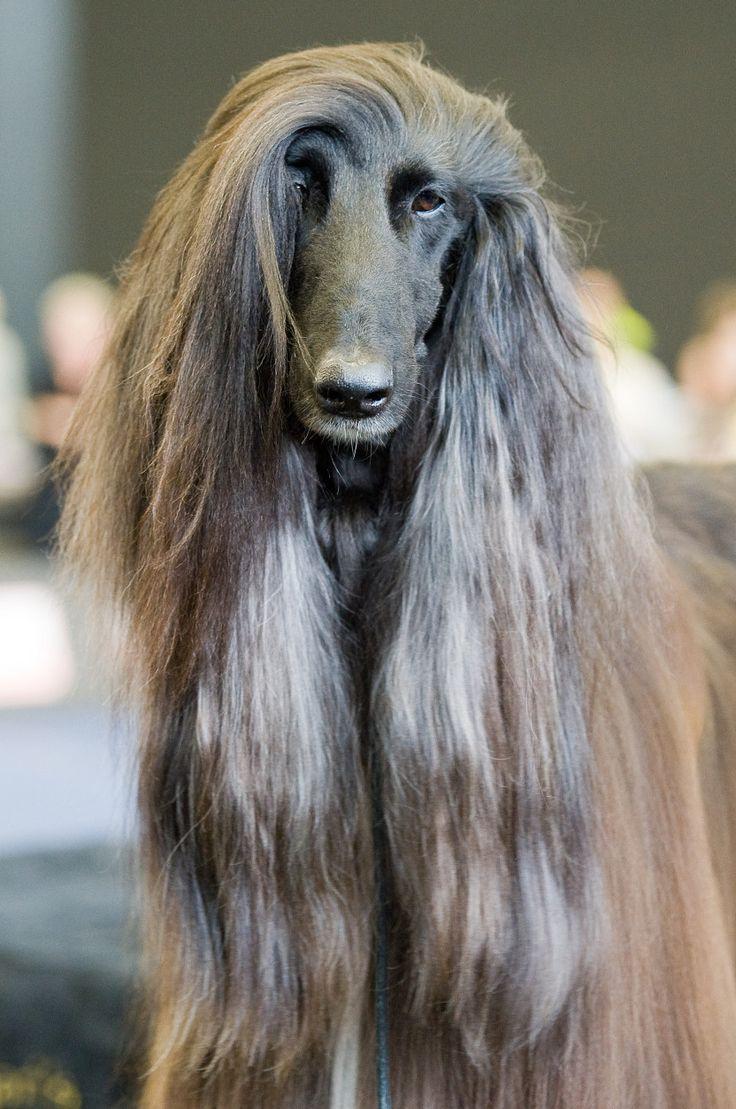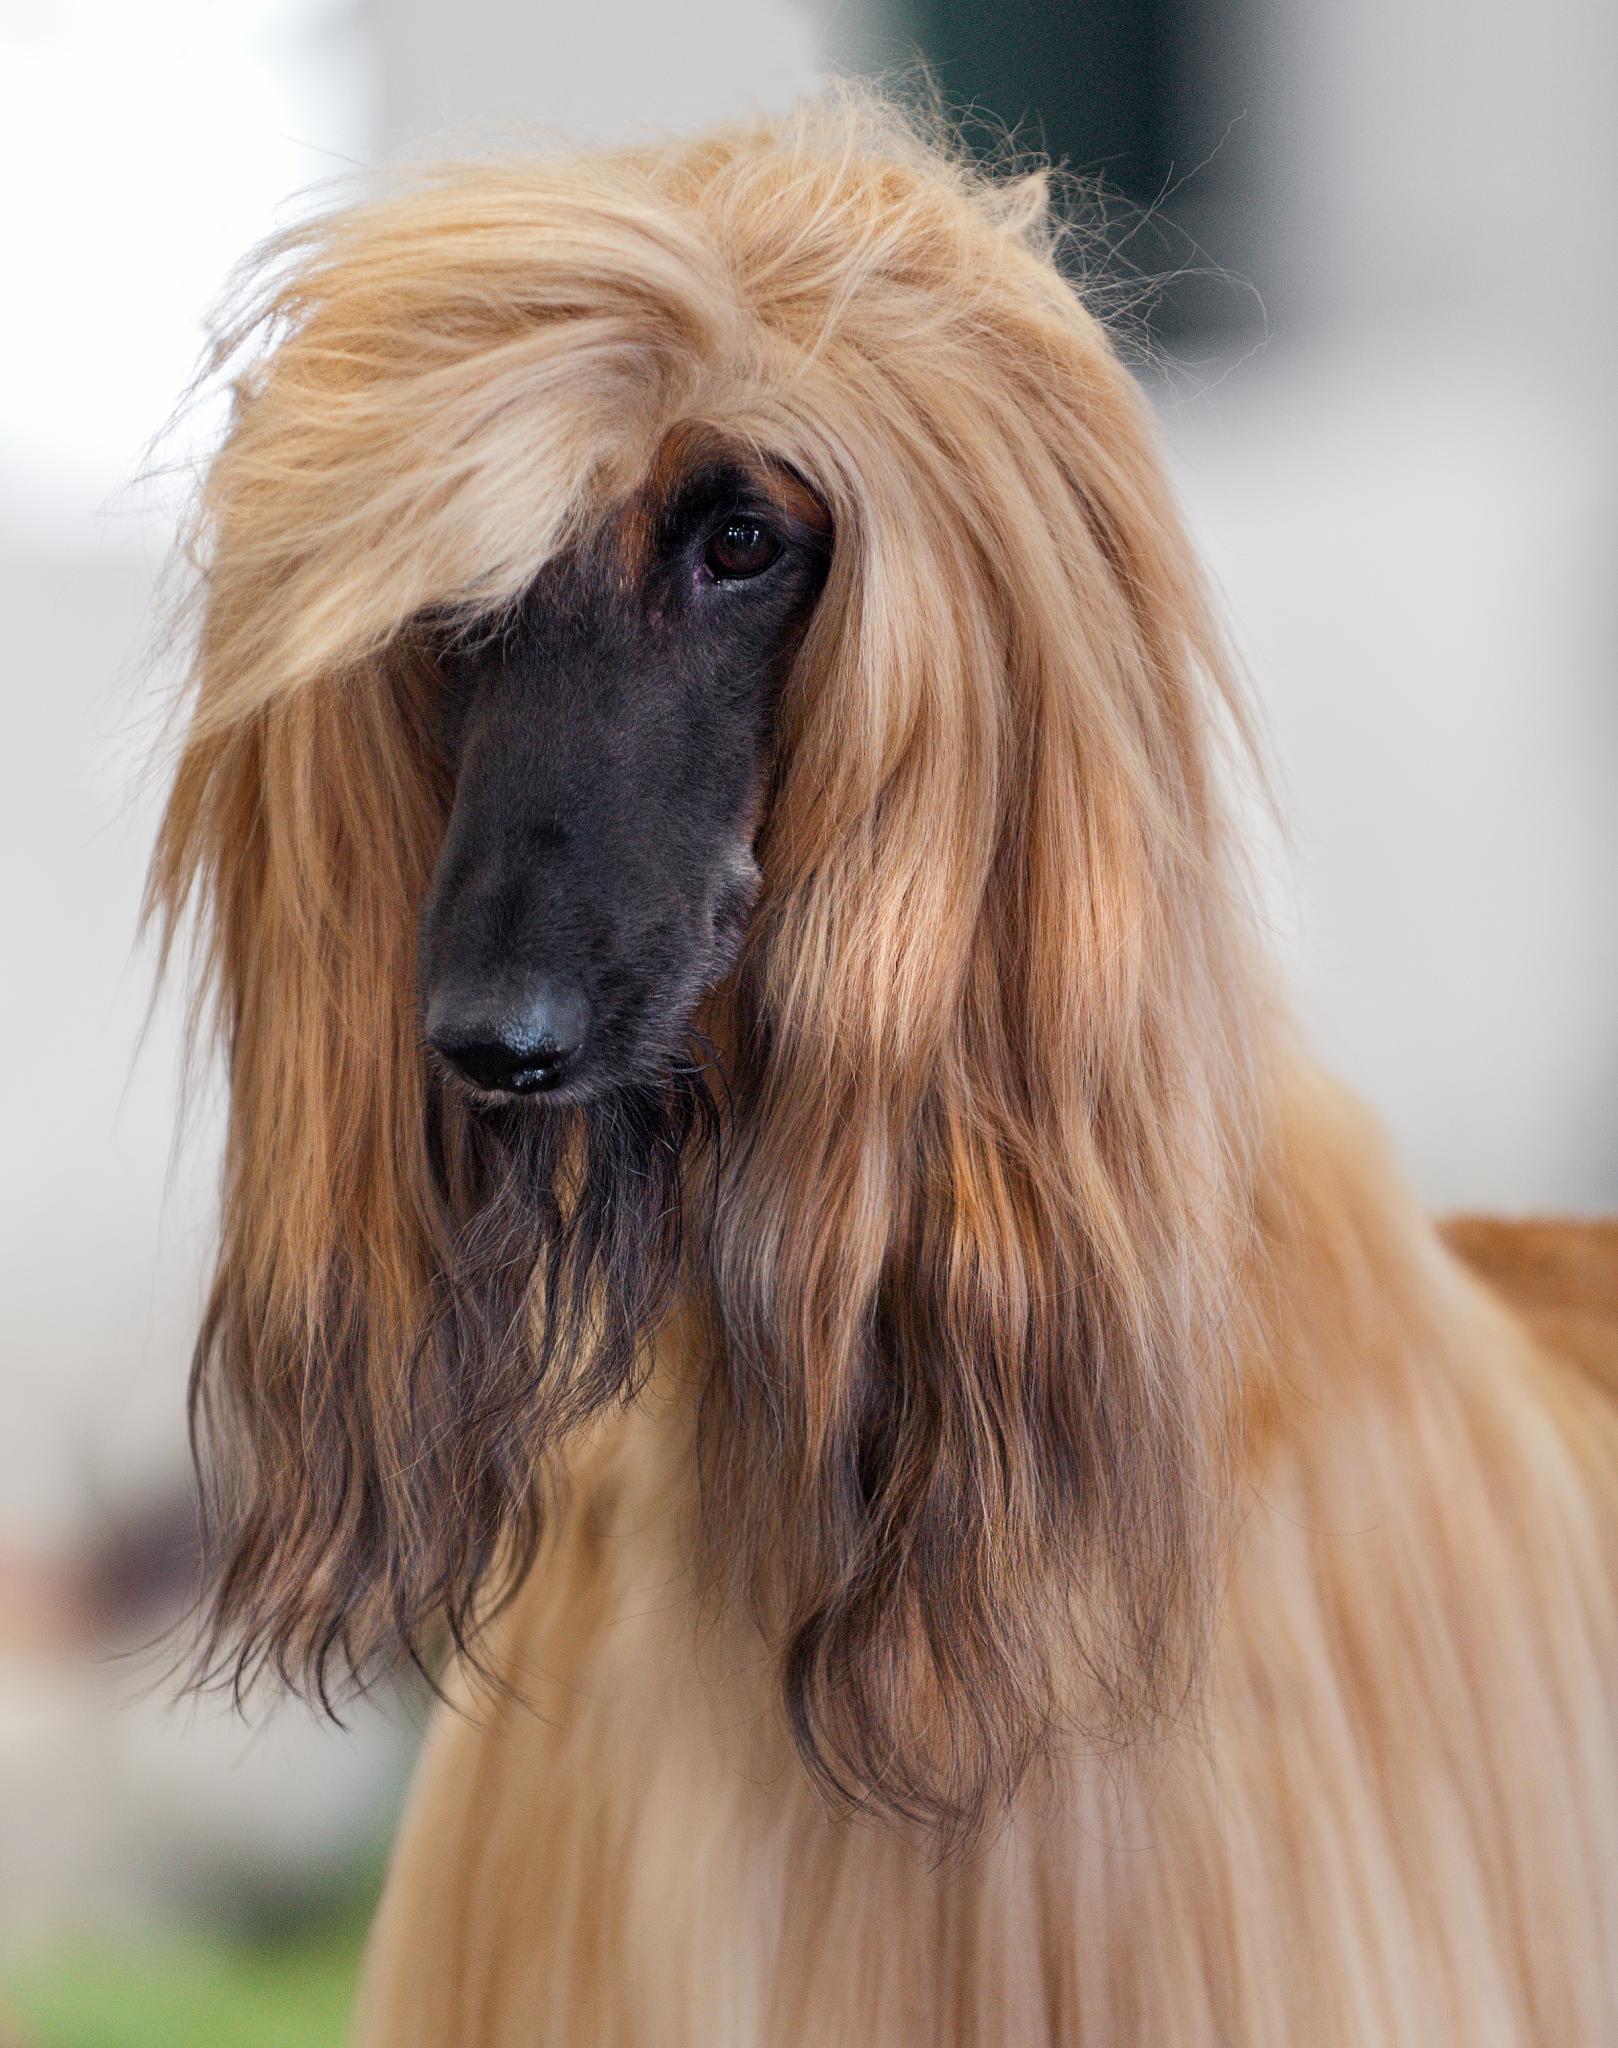The first image is the image on the left, the second image is the image on the right. Given the left and right images, does the statement "At least one of the dogs is standing, and you can see a full body shot of the standing dog." hold true? Answer yes or no. No. The first image is the image on the left, the second image is the image on the right. Analyze the images presented: Is the assertion "In at least one image, there is a single dog with brown tipped ears and small curled tail, facing left with its feet on grass." valid? Answer yes or no. No. 